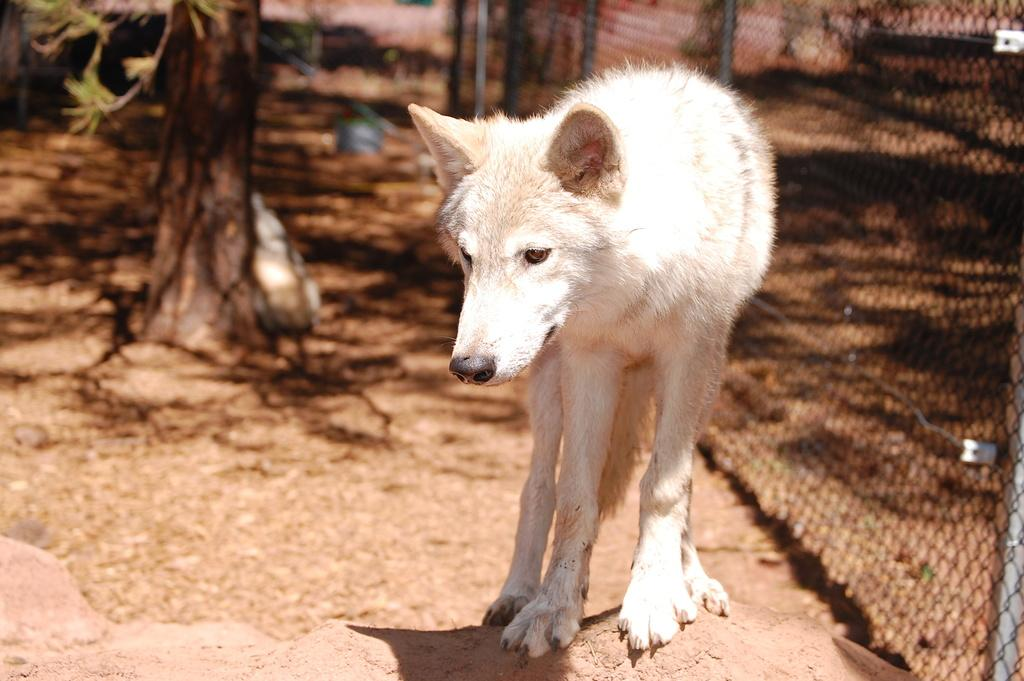What type of animal is present in the image? There is a dog in the image. What can be seen in the background of the image? There is a tree and a fence in the background of the image. What song is the dog singing in the image? Dogs do not sing songs, so there is no song being sung by the dog in the image. 